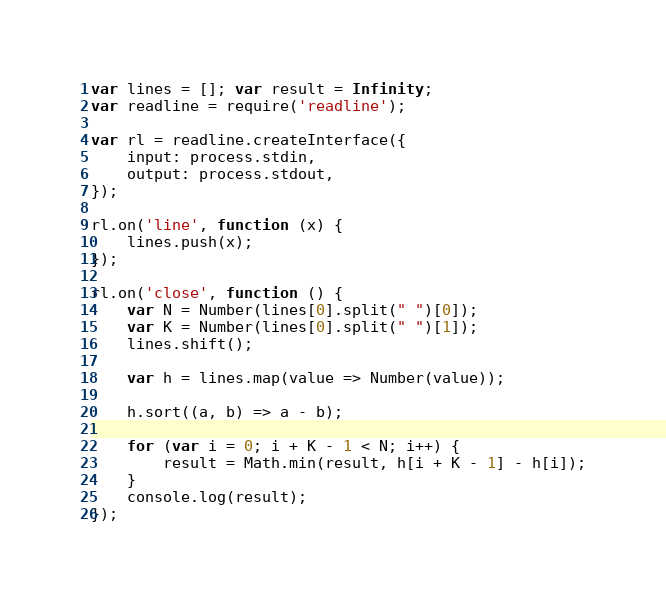<code> <loc_0><loc_0><loc_500><loc_500><_JavaScript_>var lines = []; var result = Infinity;
var readline = require('readline');

var rl = readline.createInterface({
    input: process.stdin,
    output: process.stdout,
});

rl.on('line', function (x) {
    lines.push(x);
});

rl.on('close', function () {
    var N = Number(lines[0].split(" ")[0]);
    var K = Number(lines[0].split(" ")[1]);
    lines.shift();

    var h = lines.map(value => Number(value));

    h.sort((a, b) => a - b);

    for (var i = 0; i + K - 1 < N; i++) {
        result = Math.min(result, h[i + K - 1] - h[i]);
    }
    console.log(result);
});</code> 